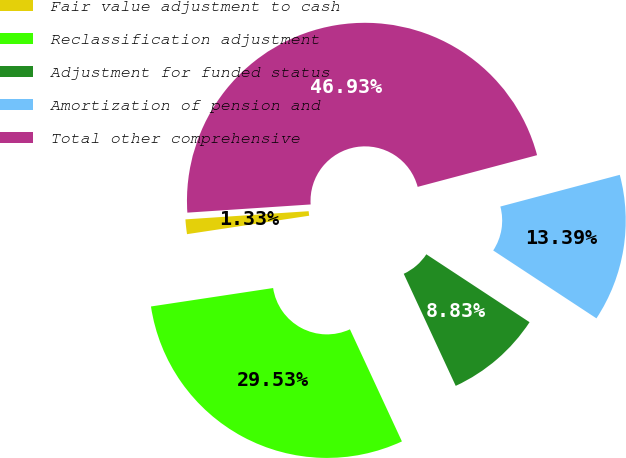<chart> <loc_0><loc_0><loc_500><loc_500><pie_chart><fcel>Fair value adjustment to cash<fcel>Reclassification adjustment<fcel>Adjustment for funded status<fcel>Amortization of pension and<fcel>Total other comprehensive<nl><fcel>1.33%<fcel>29.53%<fcel>8.83%<fcel>13.39%<fcel>46.93%<nl></chart> 